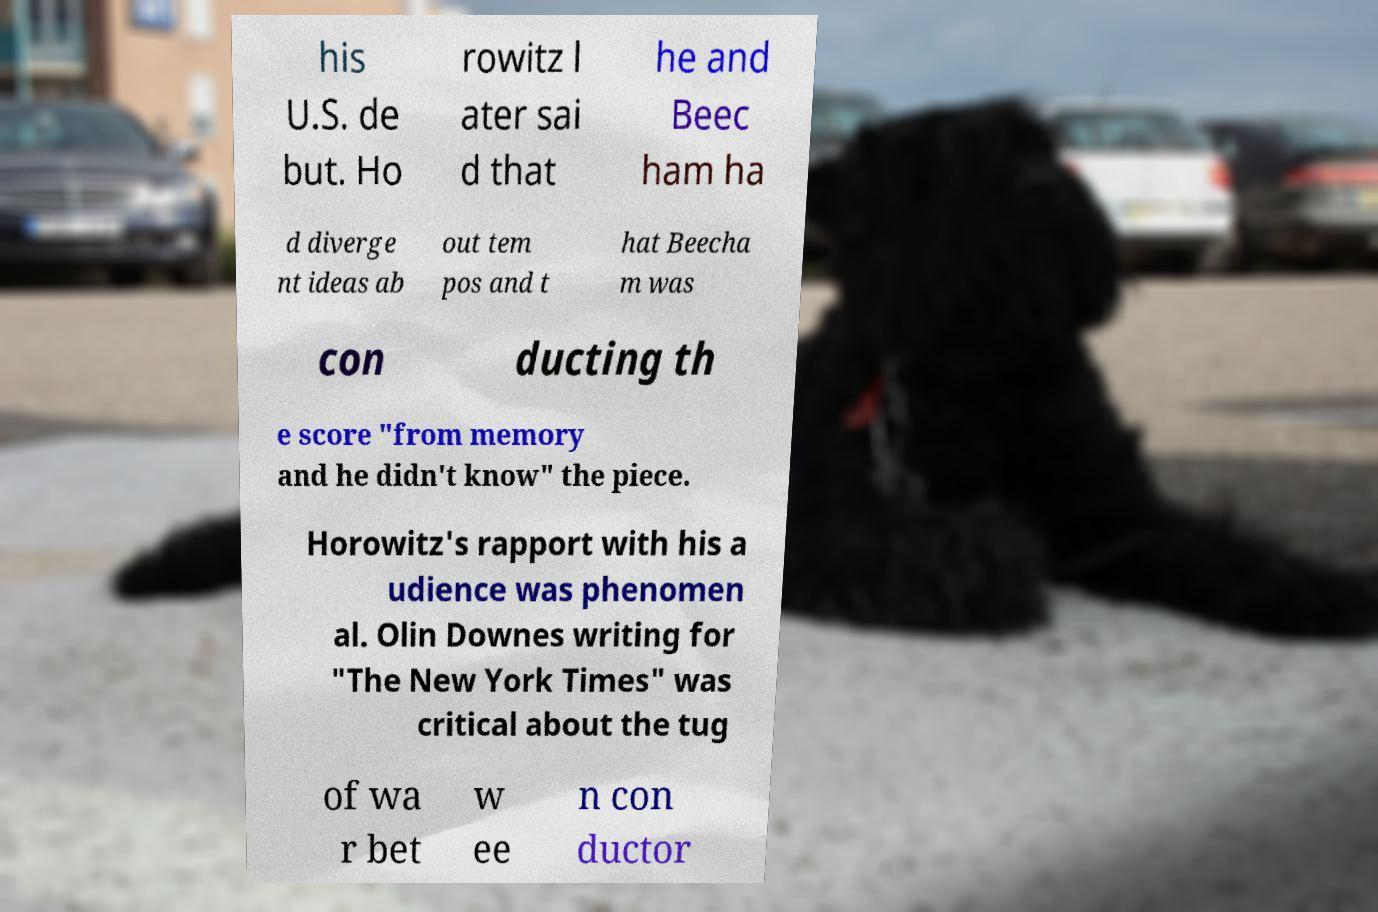For documentation purposes, I need the text within this image transcribed. Could you provide that? his U.S. de but. Ho rowitz l ater sai d that he and Beec ham ha d diverge nt ideas ab out tem pos and t hat Beecha m was con ducting th e score "from memory and he didn't know" the piece. Horowitz's rapport with his a udience was phenomen al. Olin Downes writing for "The New York Times" was critical about the tug of wa r bet w ee n con ductor 